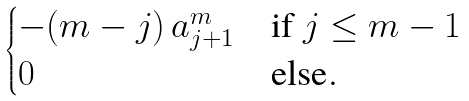Convert formula to latex. <formula><loc_0><loc_0><loc_500><loc_500>\begin{cases} - ( m - j ) \, a _ { j + 1 } ^ { m } & \text {if $j \leq m-1$} \\ 0 & \text {else} . \\ \end{cases}</formula> 